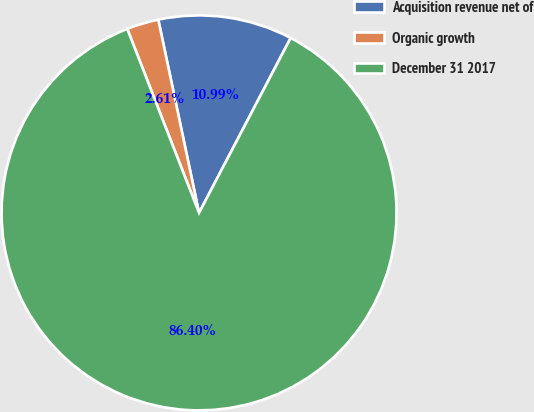<chart> <loc_0><loc_0><loc_500><loc_500><pie_chart><fcel>Acquisition revenue net of<fcel>Organic growth<fcel>December 31 2017<nl><fcel>10.99%<fcel>2.61%<fcel>86.4%<nl></chart> 